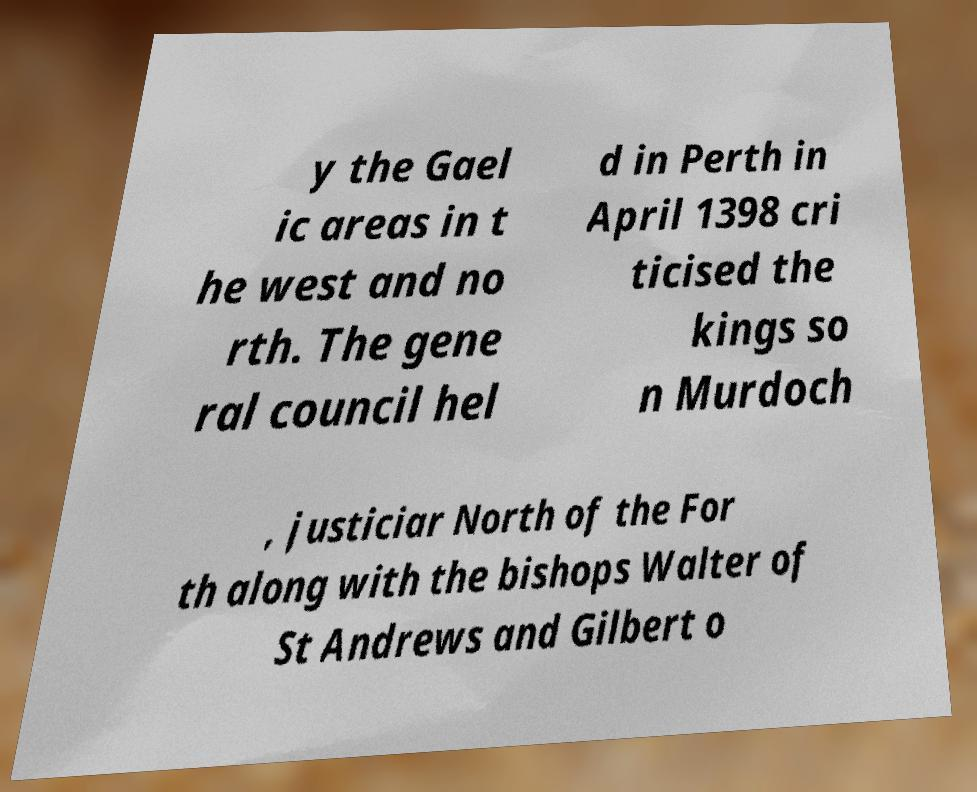For documentation purposes, I need the text within this image transcribed. Could you provide that? y the Gael ic areas in t he west and no rth. The gene ral council hel d in Perth in April 1398 cri ticised the kings so n Murdoch , justiciar North of the For th along with the bishops Walter of St Andrews and Gilbert o 